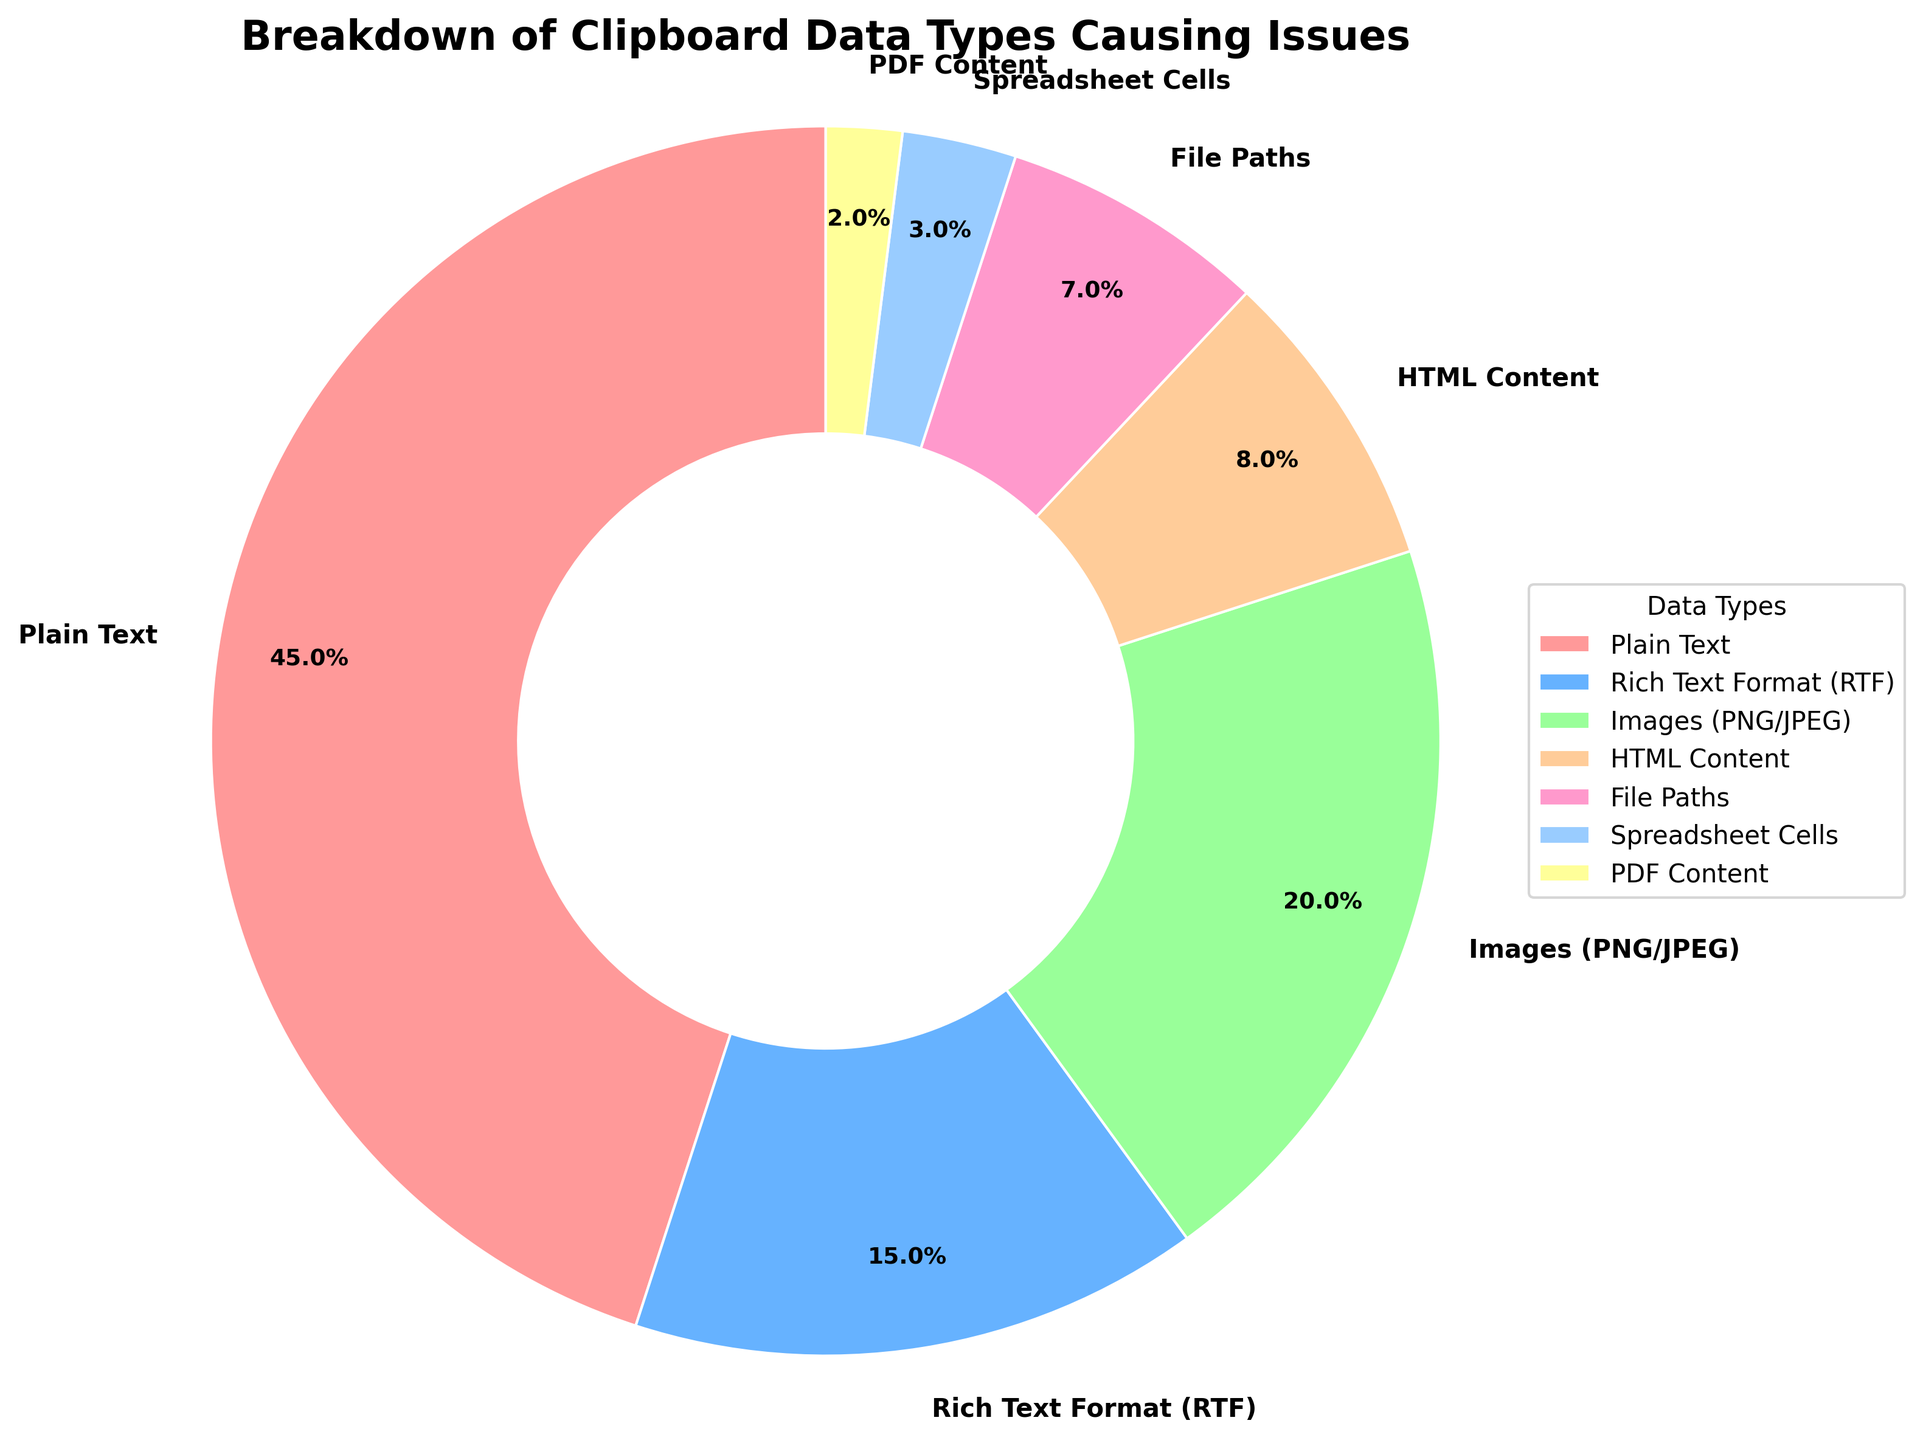Which data type in the pie chart causes the most problems? By looking at the pie chart, the largest segment can be identified. The largest segment corresponds to "Plain Text".
Answer: Plain Text Which data type causes the least problems? By examining the pie chart, the smallest segment is observed. The smallest segment corresponds to "PDF Content".
Answer: PDF Content What is the difference in percentage between "Plain Text" and "Rich Text Format (RTF)"? "Plain Text" is 45% while "Rich Text Format (RTF)" is 15%. The difference is calculated as 45% - 15%.
Answer: 30% Do "Images (PNG/JPEG)" cause more issues than "File Paths"? By comparing the two segments, "Images (PNG/JPEG)" shows 20% and "File Paths" shows 7%. Therefore, "Images (PNG/JPEG)" cause more problems than "File Paths".
Answer: Yes What is the combined percentage of issues caused by "HTML Content" and "Spreadsheet Cells"? "HTML Content" is 8% and "Spreadsheet Cells" is 3%. The combined percentage is calculated as 8% + 3%.
Answer: 11% Does "Rich Text Format (RTF)" cause more issues than the combination of "Spreadsheet Cells" and "PDF Content"? "Rich Text Format (RTF)" is 15%, while "Spreadsheet Cells" is 3% and "PDF Content" is 2%. So, the combined is 5%. Since 15% > 5%, "Rich Text Format (RTF)" causes more issues.
Answer: Yes Which data types contribute to less than 10% of the total issues each? By inspecting each segment, "HTML Content" (8%), "File Paths" (7%), "Spreadsheet Cells" (3%), and "PDF Content" (2%) each contribute less than 10%.
Answer: HTML Content, File Paths, Spreadsheet Cells, PDF Content What color represents the "Images (PNG/JPEG)" segment in the pie chart? By identifying the segment labeled "Images (PNG/JPEG)", it is seen that this segment is colored green.
Answer: Green What is the total percentage of issues caused by "Plain Text", "Images (PNG/JPEG)", and "File Paths" combined? "Plain Text" is 45%, "Images (PNG/JPEG)" is 20%, and "File Paths" is 7%. The total combined percentage is 45% + 20% + 7%.
Answer: 72% Is the percentage of issues caused by "HTML Content" closer to that of "File Paths" or "Rich Text Format (RTF)"? "HTML Content" is 8%, "File Paths" is 7%, and "Rich Text Format (RTF)" is 15%. The difference to "File Paths" is 1% (8% - 7%) and to "RTF" is 7% (15% - 8%). Therefore, it's closer to "File Paths".
Answer: File Paths 